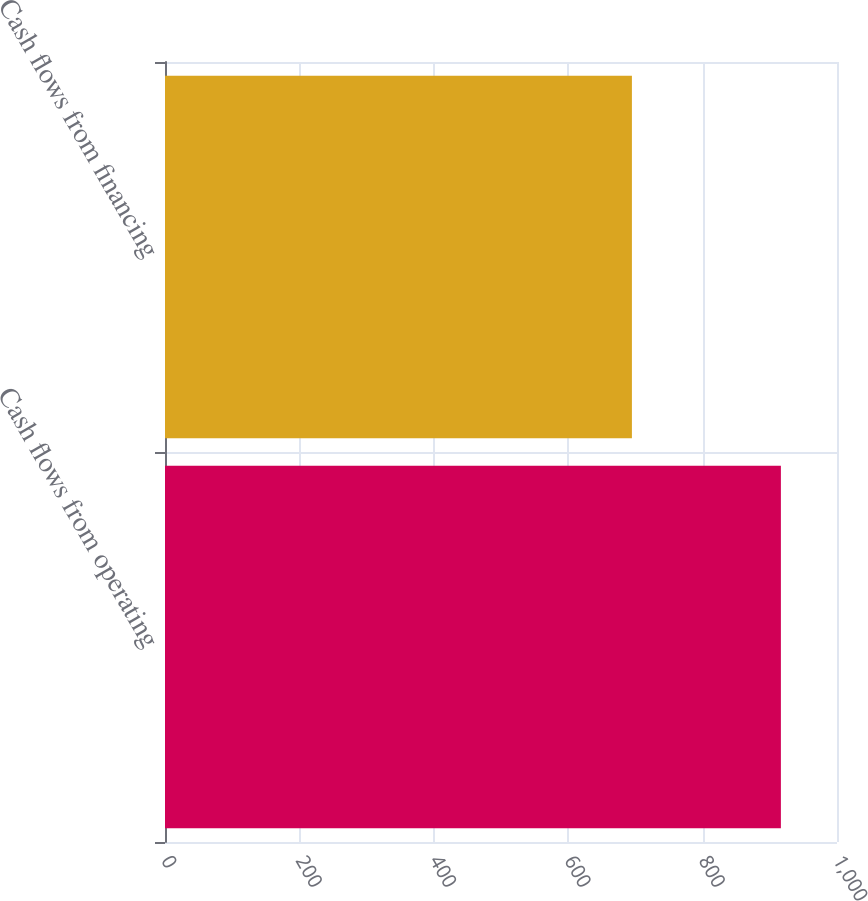Convert chart. <chart><loc_0><loc_0><loc_500><loc_500><bar_chart><fcel>Cash flows from operating<fcel>Cash flows from financing<nl><fcel>916.5<fcel>694.8<nl></chart> 